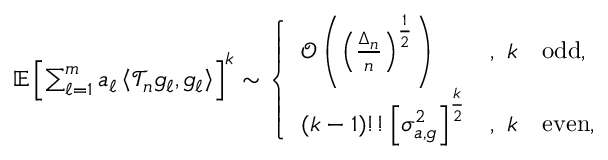Convert formula to latex. <formula><loc_0><loc_0><loc_500><loc_500>\begin{array} { r } { \mathbb { E } \left [ \sum _ { \ell = 1 } ^ { m } a _ { \ell } \left \langle \mathcal { T } _ { n } g _ { \ell } , g _ { \ell } \right \rangle \right ] ^ { k } \sim \left \{ \begin{array} { l l } { \mathcal { O } \left ( \left ( \frac { \Delta _ { n } } { n } \right ) ^ { \frac { 1 } { 2 } } \right ) } & { , \ k \quad o d d , } \\ { ( k - 1 ) ! ! \left [ \sigma _ { a , g } ^ { 2 } \right ] ^ { \frac { k } { 2 } } } & { , \ k \quad e v e n , } \end{array} } \end{array}</formula> 